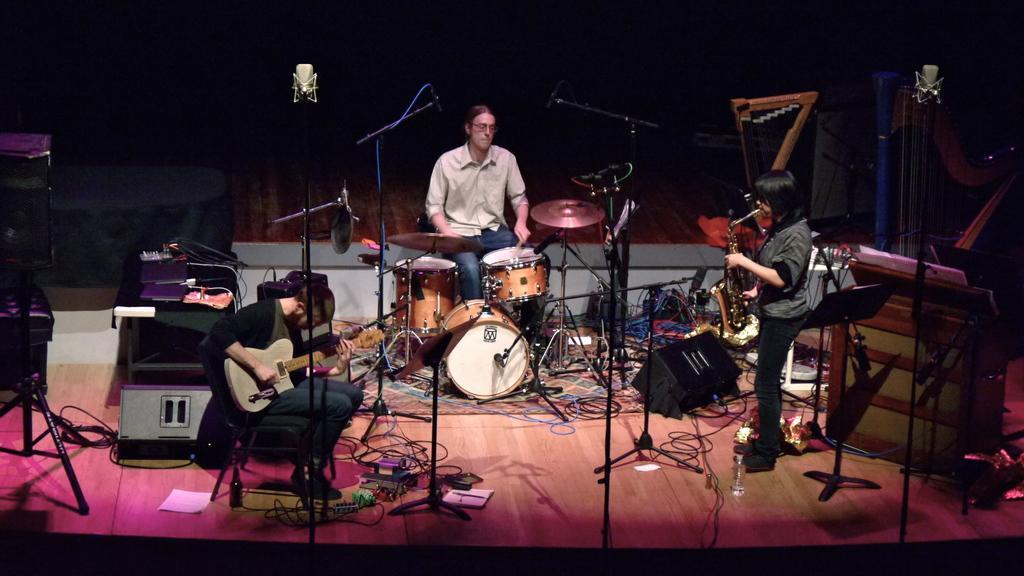How would you summarize this image in a sentence or two? In this picture we can see three persons playing musical instruments such as guitar, drums, saxophone and in front of them we can see wires, mic stand, mic, speakers and in the background we can see wall and it is dark. 